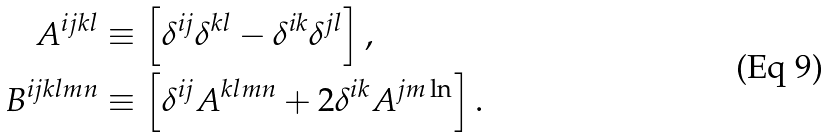<formula> <loc_0><loc_0><loc_500><loc_500>A ^ { i j k l } & \equiv \left [ \delta ^ { i j } \delta ^ { k l } - \delta ^ { i k } \delta ^ { j l } \right ] , \\ B ^ { i j k l m n } & \equiv \left [ \delta ^ { i j } A ^ { k l m n } + 2 \delta ^ { i k } A ^ { j m \ln } \right ] .</formula> 